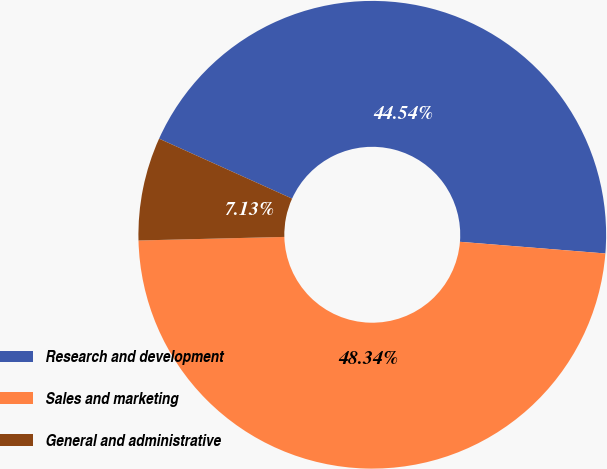Convert chart. <chart><loc_0><loc_0><loc_500><loc_500><pie_chart><fcel>Research and development<fcel>Sales and marketing<fcel>General and administrative<nl><fcel>44.54%<fcel>48.34%<fcel>7.13%<nl></chart> 